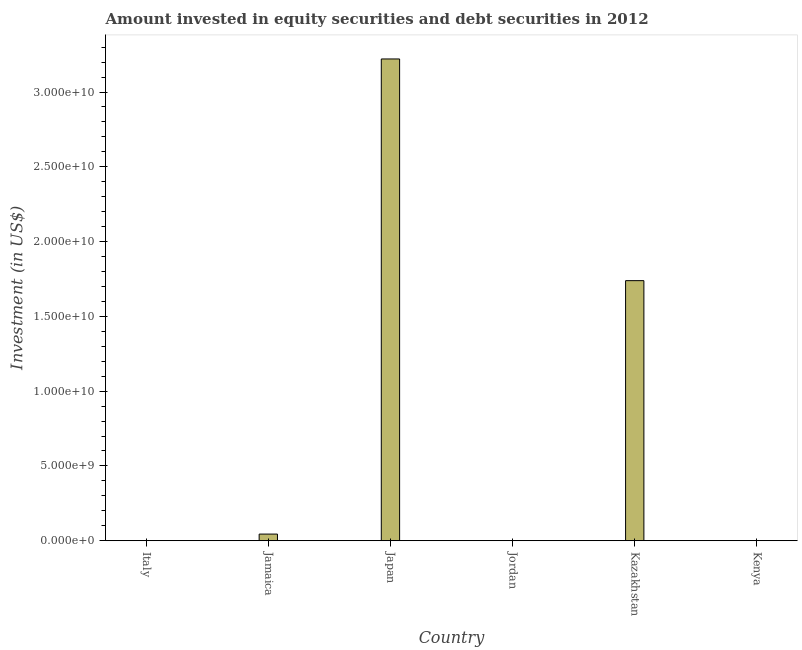Does the graph contain grids?
Your answer should be very brief. No. What is the title of the graph?
Give a very brief answer. Amount invested in equity securities and debt securities in 2012. What is the label or title of the Y-axis?
Offer a very short reply. Investment (in US$). What is the portfolio investment in Japan?
Make the answer very short. 3.22e+1. Across all countries, what is the maximum portfolio investment?
Ensure brevity in your answer.  3.22e+1. What is the sum of the portfolio investment?
Provide a succinct answer. 5.01e+1. What is the difference between the portfolio investment in Jamaica and Japan?
Provide a short and direct response. -3.18e+1. What is the average portfolio investment per country?
Your response must be concise. 8.34e+09. What is the median portfolio investment?
Provide a short and direct response. 2.28e+08. In how many countries, is the portfolio investment greater than 25000000000 US$?
Offer a terse response. 1. What is the ratio of the portfolio investment in Jamaica to that in Japan?
Give a very brief answer. 0.01. Is the portfolio investment in Kazakhstan less than that in Kenya?
Your answer should be compact. No. Is the difference between the portfolio investment in Japan and Kazakhstan greater than the difference between any two countries?
Provide a succinct answer. No. What is the difference between the highest and the second highest portfolio investment?
Your response must be concise. 1.48e+1. Is the sum of the portfolio investment in Japan and Kazakhstan greater than the maximum portfolio investment across all countries?
Keep it short and to the point. Yes. What is the difference between the highest and the lowest portfolio investment?
Ensure brevity in your answer.  3.22e+1. How many bars are there?
Your response must be concise. 4. Are all the bars in the graph horizontal?
Your response must be concise. No. What is the Investment (in US$) of Italy?
Offer a very short reply. 0. What is the Investment (in US$) of Jamaica?
Offer a very short reply. 4.43e+08. What is the Investment (in US$) in Japan?
Provide a short and direct response. 3.22e+1. What is the Investment (in US$) of Kazakhstan?
Provide a succinct answer. 1.74e+1. What is the Investment (in US$) in Kenya?
Your answer should be compact. 1.36e+07. What is the difference between the Investment (in US$) in Jamaica and Japan?
Give a very brief answer. -3.18e+1. What is the difference between the Investment (in US$) in Jamaica and Kazakhstan?
Provide a succinct answer. -1.69e+1. What is the difference between the Investment (in US$) in Jamaica and Kenya?
Give a very brief answer. 4.30e+08. What is the difference between the Investment (in US$) in Japan and Kazakhstan?
Ensure brevity in your answer.  1.48e+1. What is the difference between the Investment (in US$) in Japan and Kenya?
Provide a short and direct response. 3.22e+1. What is the difference between the Investment (in US$) in Kazakhstan and Kenya?
Offer a very short reply. 1.74e+1. What is the ratio of the Investment (in US$) in Jamaica to that in Japan?
Your answer should be compact. 0.01. What is the ratio of the Investment (in US$) in Jamaica to that in Kazakhstan?
Offer a terse response. 0.03. What is the ratio of the Investment (in US$) in Jamaica to that in Kenya?
Offer a very short reply. 32.61. What is the ratio of the Investment (in US$) in Japan to that in Kazakhstan?
Your response must be concise. 1.85. What is the ratio of the Investment (in US$) in Japan to that in Kenya?
Make the answer very short. 2369.99. What is the ratio of the Investment (in US$) in Kazakhstan to that in Kenya?
Ensure brevity in your answer.  1279.38. 